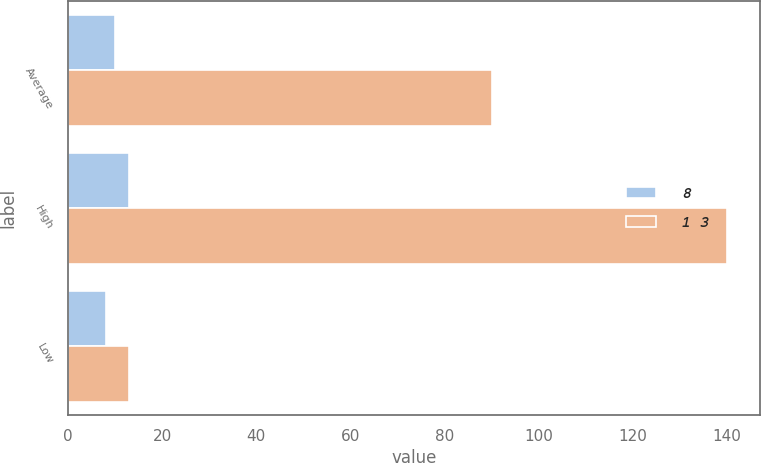<chart> <loc_0><loc_0><loc_500><loc_500><stacked_bar_chart><ecel><fcel>Average<fcel>High<fcel>Low<nl><fcel>8<fcel>10<fcel>13<fcel>8<nl><fcel>1 3<fcel>90<fcel>140<fcel>13<nl></chart> 